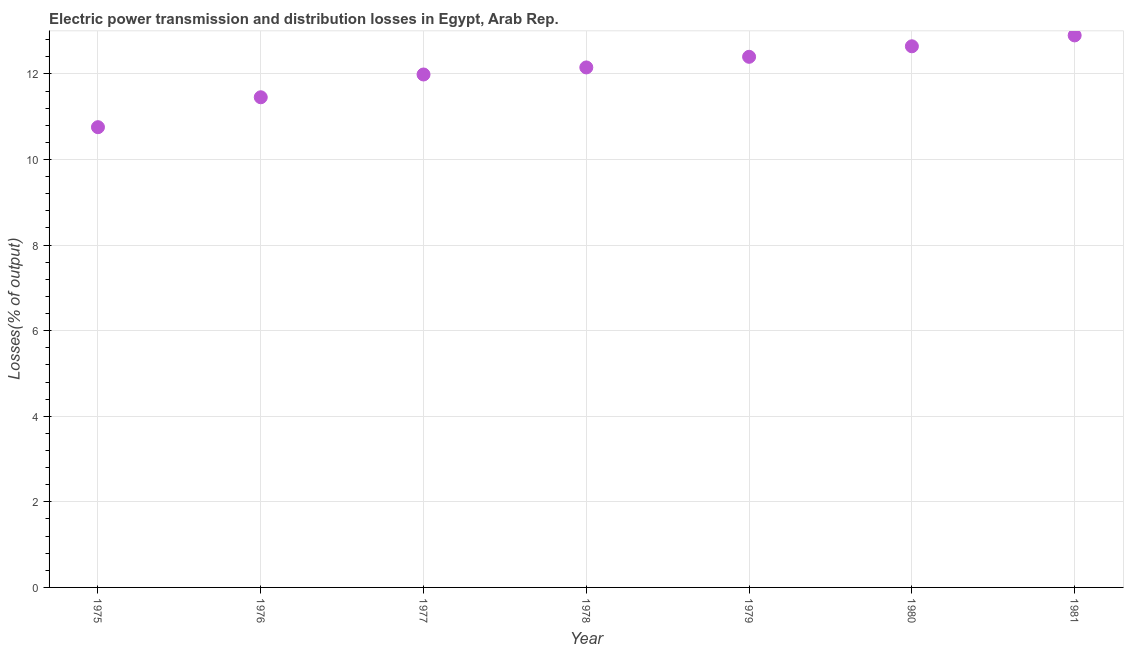What is the electric power transmission and distribution losses in 1976?
Your answer should be compact. 11.45. Across all years, what is the maximum electric power transmission and distribution losses?
Offer a very short reply. 12.9. Across all years, what is the minimum electric power transmission and distribution losses?
Make the answer very short. 10.76. In which year was the electric power transmission and distribution losses maximum?
Provide a succinct answer. 1981. In which year was the electric power transmission and distribution losses minimum?
Keep it short and to the point. 1975. What is the sum of the electric power transmission and distribution losses?
Your answer should be compact. 84.29. What is the difference between the electric power transmission and distribution losses in 1976 and 1981?
Your response must be concise. -1.45. What is the average electric power transmission and distribution losses per year?
Ensure brevity in your answer.  12.04. What is the median electric power transmission and distribution losses?
Offer a very short reply. 12.15. In how many years, is the electric power transmission and distribution losses greater than 9.6 %?
Provide a succinct answer. 7. Do a majority of the years between 1975 and 1981 (inclusive) have electric power transmission and distribution losses greater than 6 %?
Keep it short and to the point. Yes. What is the ratio of the electric power transmission and distribution losses in 1976 to that in 1979?
Provide a short and direct response. 0.92. What is the difference between the highest and the second highest electric power transmission and distribution losses?
Keep it short and to the point. 0.25. Is the sum of the electric power transmission and distribution losses in 1978 and 1980 greater than the maximum electric power transmission and distribution losses across all years?
Provide a succinct answer. Yes. What is the difference between the highest and the lowest electric power transmission and distribution losses?
Give a very brief answer. 2.14. How many dotlines are there?
Ensure brevity in your answer.  1. What is the difference between two consecutive major ticks on the Y-axis?
Ensure brevity in your answer.  2. Are the values on the major ticks of Y-axis written in scientific E-notation?
Keep it short and to the point. No. What is the title of the graph?
Keep it short and to the point. Electric power transmission and distribution losses in Egypt, Arab Rep. What is the label or title of the Y-axis?
Ensure brevity in your answer.  Losses(% of output). What is the Losses(% of output) in 1975?
Provide a succinct answer. 10.76. What is the Losses(% of output) in 1976?
Your answer should be compact. 11.45. What is the Losses(% of output) in 1977?
Offer a very short reply. 11.99. What is the Losses(% of output) in 1978?
Provide a short and direct response. 12.15. What is the Losses(% of output) in 1979?
Provide a succinct answer. 12.4. What is the Losses(% of output) in 1980?
Keep it short and to the point. 12.65. What is the Losses(% of output) in 1981?
Ensure brevity in your answer.  12.9. What is the difference between the Losses(% of output) in 1975 and 1976?
Your answer should be compact. -0.7. What is the difference between the Losses(% of output) in 1975 and 1977?
Keep it short and to the point. -1.23. What is the difference between the Losses(% of output) in 1975 and 1978?
Ensure brevity in your answer.  -1.4. What is the difference between the Losses(% of output) in 1975 and 1979?
Your answer should be compact. -1.64. What is the difference between the Losses(% of output) in 1975 and 1980?
Provide a short and direct response. -1.89. What is the difference between the Losses(% of output) in 1975 and 1981?
Keep it short and to the point. -2.14. What is the difference between the Losses(% of output) in 1976 and 1977?
Offer a very short reply. -0.53. What is the difference between the Losses(% of output) in 1976 and 1978?
Your answer should be very brief. -0.7. What is the difference between the Losses(% of output) in 1976 and 1979?
Make the answer very short. -0.95. What is the difference between the Losses(% of output) in 1976 and 1980?
Your response must be concise. -1.19. What is the difference between the Losses(% of output) in 1976 and 1981?
Give a very brief answer. -1.45. What is the difference between the Losses(% of output) in 1977 and 1978?
Ensure brevity in your answer.  -0.16. What is the difference between the Losses(% of output) in 1977 and 1979?
Ensure brevity in your answer.  -0.41. What is the difference between the Losses(% of output) in 1977 and 1980?
Provide a succinct answer. -0.66. What is the difference between the Losses(% of output) in 1977 and 1981?
Give a very brief answer. -0.91. What is the difference between the Losses(% of output) in 1978 and 1979?
Offer a very short reply. -0.25. What is the difference between the Losses(% of output) in 1978 and 1980?
Your answer should be compact. -0.49. What is the difference between the Losses(% of output) in 1978 and 1981?
Ensure brevity in your answer.  -0.75. What is the difference between the Losses(% of output) in 1979 and 1980?
Your answer should be very brief. -0.25. What is the difference between the Losses(% of output) in 1979 and 1981?
Offer a very short reply. -0.5. What is the difference between the Losses(% of output) in 1980 and 1981?
Ensure brevity in your answer.  -0.25. What is the ratio of the Losses(% of output) in 1975 to that in 1976?
Make the answer very short. 0.94. What is the ratio of the Losses(% of output) in 1975 to that in 1977?
Keep it short and to the point. 0.9. What is the ratio of the Losses(% of output) in 1975 to that in 1978?
Keep it short and to the point. 0.89. What is the ratio of the Losses(% of output) in 1975 to that in 1979?
Offer a terse response. 0.87. What is the ratio of the Losses(% of output) in 1975 to that in 1980?
Give a very brief answer. 0.85. What is the ratio of the Losses(% of output) in 1975 to that in 1981?
Make the answer very short. 0.83. What is the ratio of the Losses(% of output) in 1976 to that in 1977?
Provide a succinct answer. 0.96. What is the ratio of the Losses(% of output) in 1976 to that in 1978?
Your answer should be very brief. 0.94. What is the ratio of the Losses(% of output) in 1976 to that in 1979?
Give a very brief answer. 0.92. What is the ratio of the Losses(% of output) in 1976 to that in 1980?
Your answer should be compact. 0.91. What is the ratio of the Losses(% of output) in 1976 to that in 1981?
Ensure brevity in your answer.  0.89. What is the ratio of the Losses(% of output) in 1977 to that in 1979?
Make the answer very short. 0.97. What is the ratio of the Losses(% of output) in 1977 to that in 1980?
Your answer should be compact. 0.95. What is the ratio of the Losses(% of output) in 1977 to that in 1981?
Offer a very short reply. 0.93. What is the ratio of the Losses(% of output) in 1978 to that in 1981?
Make the answer very short. 0.94. What is the ratio of the Losses(% of output) in 1979 to that in 1980?
Give a very brief answer. 0.98. 